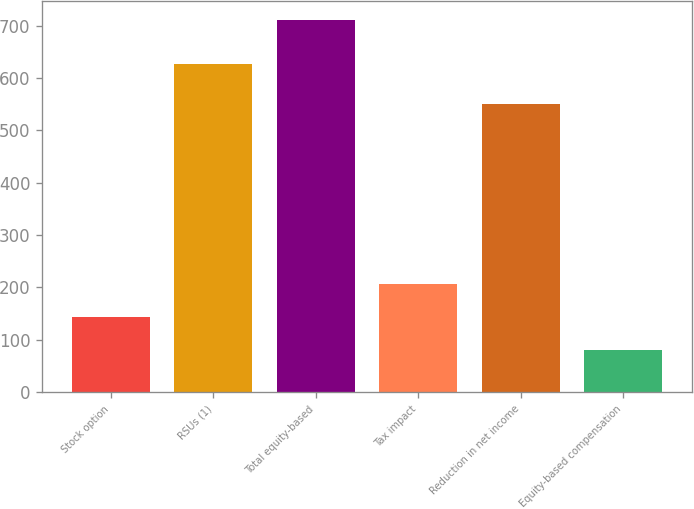Convert chart. <chart><loc_0><loc_0><loc_500><loc_500><bar_chart><fcel>Stock option<fcel>RSUs (1)<fcel>Total equity-based<fcel>Tax impact<fcel>Reduction in net income<fcel>Equity-based compensation<nl><fcel>144<fcel>627<fcel>711<fcel>207<fcel>550<fcel>81<nl></chart> 